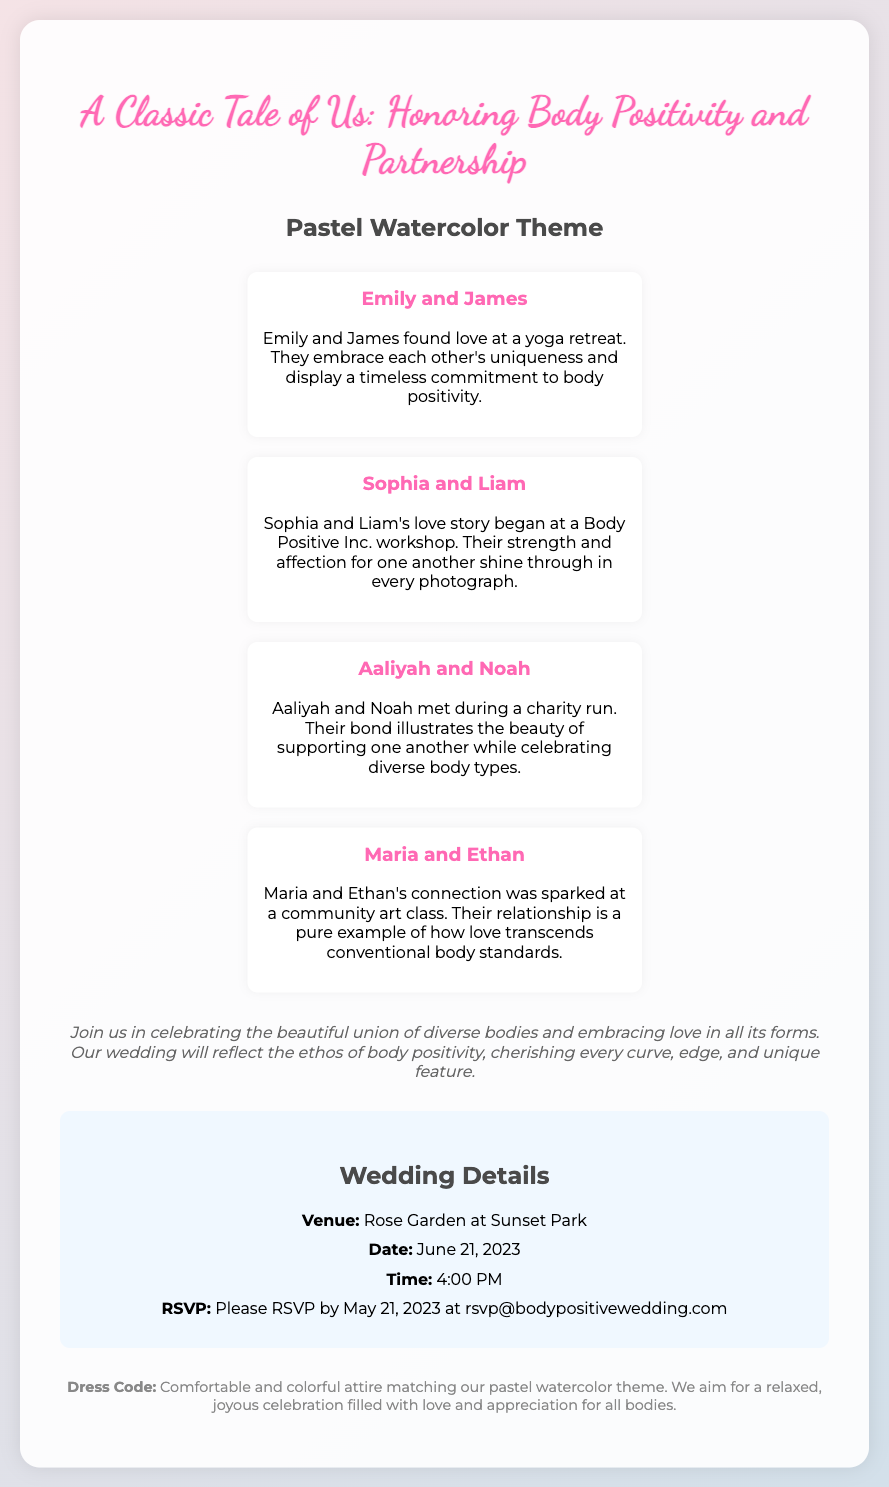What is the theme of the wedding invitation? The theme of the wedding invitation is indicated as "Pastel Watercolor Theme".
Answer: Pastel Watercolor Theme Who are the first couple mentioned in the invitation? The first couple mentioned is Emily and James.
Answer: Emily and James What is the date of the wedding? The specific date for the wedding is given in the details section.
Answer: June 21, 2023 What venue will host the wedding? The venue where the wedding will be held is specified in the invitation.
Answer: Rose Garden at Sunset Park What is the dress code for the wedding? The dress code information is described towards the end of the invitation.
Answer: Comfortable and colorful attire How can guests RSVP for the wedding? The RSVP method is detailed in the wedding details section.
Answer: rsvp@bodypositivewedding.com What unique aspect do the couples' stories emphasize? The couples’ stories highlight a shared theme of body positivity.
Answer: Body positivity How should attendees feel about their participation? The invitation encourages a particular feeling or atmosphere which is described in the invitation message.
Answer: Relaxed and joyous celebration What is the RSVP deadline? The invitation specifies the final date for RSVPs in the details section.
Answer: May 21, 2023 